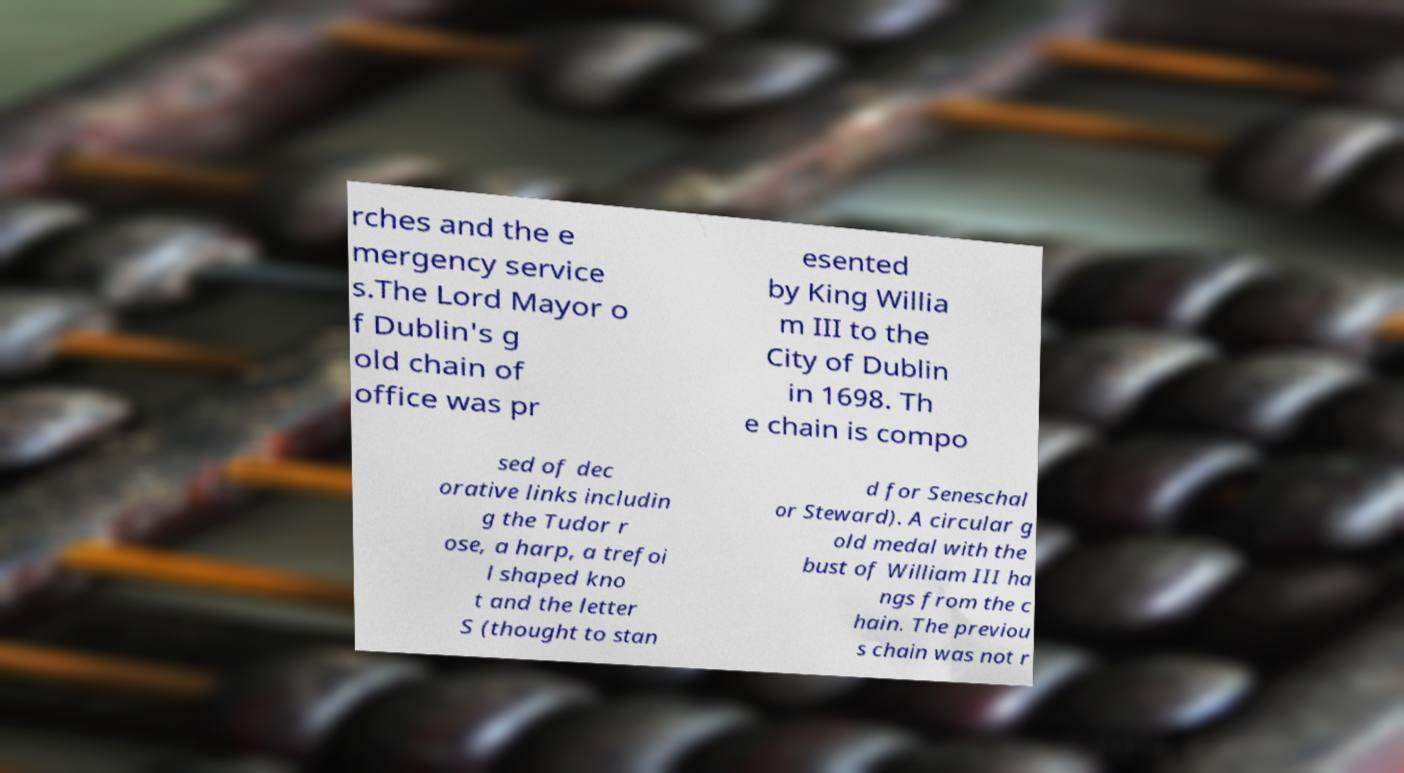There's text embedded in this image that I need extracted. Can you transcribe it verbatim? rches and the e mergency service s.The Lord Mayor o f Dublin's g old chain of office was pr esented by King Willia m III to the City of Dublin in 1698. Th e chain is compo sed of dec orative links includin g the Tudor r ose, a harp, a trefoi l shaped kno t and the letter S (thought to stan d for Seneschal or Steward). A circular g old medal with the bust of William III ha ngs from the c hain. The previou s chain was not r 